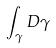Convert formula to latex. <formula><loc_0><loc_0><loc_500><loc_500>\int _ { \gamma } D \gamma</formula> 